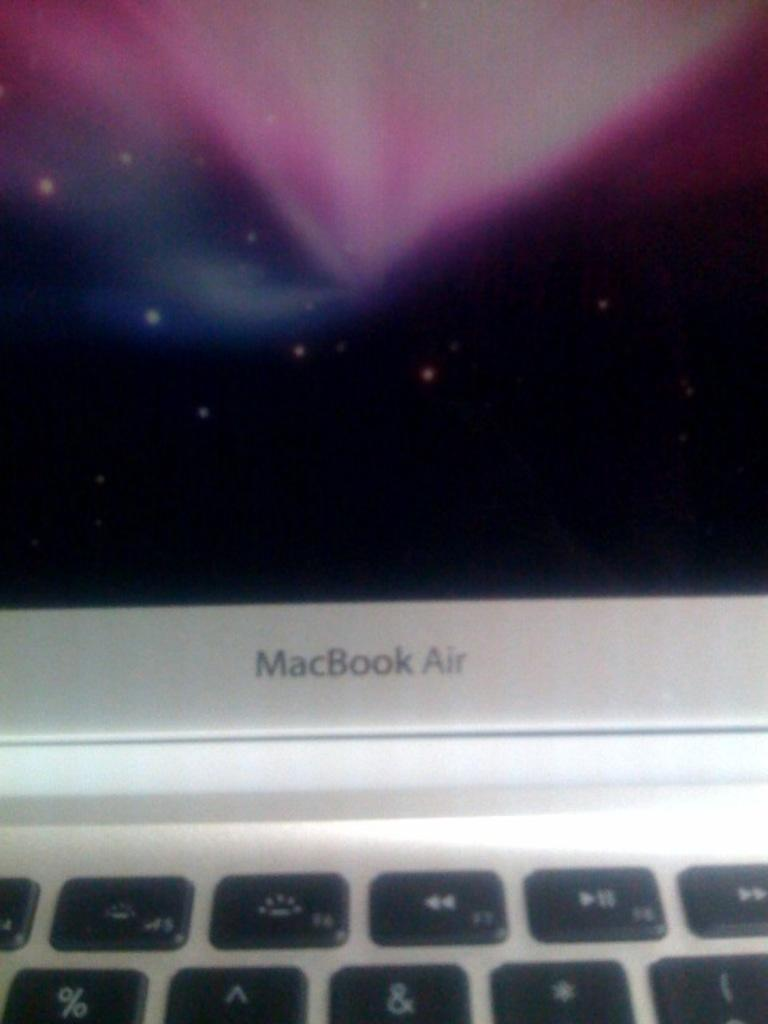<image>
Create a compact narrative representing the image presented. a shot of a MacBook Airs computer screen 